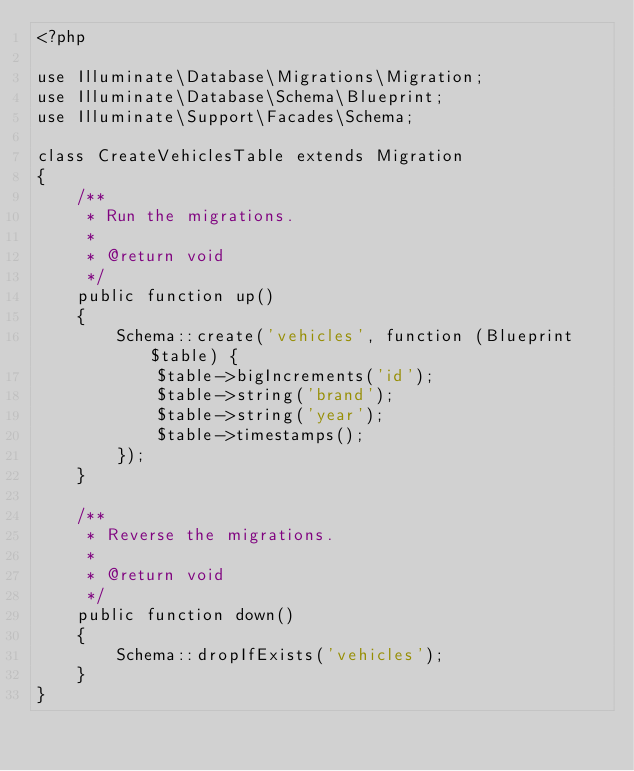Convert code to text. <code><loc_0><loc_0><loc_500><loc_500><_PHP_><?php

use Illuminate\Database\Migrations\Migration;
use Illuminate\Database\Schema\Blueprint;
use Illuminate\Support\Facades\Schema;

class CreateVehiclesTable extends Migration
{
    /**
     * Run the migrations.
     *
     * @return void
     */
    public function up()
    {
        Schema::create('vehicles', function (Blueprint $table) {
            $table->bigIncrements('id');
            $table->string('brand');
            $table->string('year');
            $table->timestamps();
        });
    }

    /**
     * Reverse the migrations.
     *
     * @return void
     */
    public function down()
    {
        Schema::dropIfExists('vehicles');
    }
}
</code> 